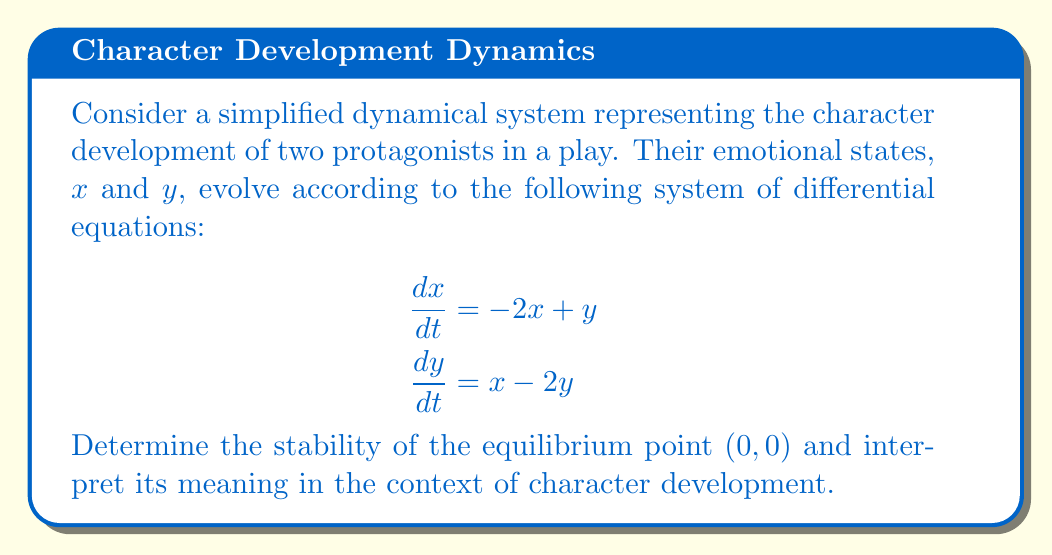Can you answer this question? To analyze the stability of the equilibrium point $(0,0)$, we'll follow these steps:

1) First, we need to find the Jacobian matrix of the system:

   $$J = \begin{bmatrix}
   \frac{\partial \dot{x}}{\partial x} & \frac{\partial \dot{x}}{\partial y} \\
   \frac{\partial \dot{y}}{\partial x} & \frac{\partial \dot{y}}{\partial y}
   \end{bmatrix} = \begin{bmatrix}
   -2 & 1 \\
   1 & -2
   \end{bmatrix}$$

2) Now, we calculate the eigenvalues of J by solving the characteristic equation:

   $$\det(J - \lambda I) = 0$$
   
   $$\begin{vmatrix}
   -2-\lambda & 1 \\
   1 & -2-\lambda
   \end{vmatrix} = 0$$
   
   $$(-2-\lambda)^2 - 1 = 0$$
   
   $$\lambda^2 + 4\lambda + 3 = 0$$

3) Solving this quadratic equation:

   $$\lambda = \frac{-4 \pm \sqrt{16 - 12}}{2} = \frac{-4 \pm \sqrt{4}}{2} = \frac{-4 \pm 2}{2}$$

   $$\lambda_1 = -3, \lambda_2 = -1$$

4) Since both eigenvalues are real and negative, the equilibrium point $(0,0)$ is a stable node.

5) Interpretation in the context of character development:
   - The stable node at $(0,0)$ represents a balanced emotional state for both characters.
   - Any perturbation from this state will eventually return to balance.
   - The eigenvalue $-1$ represents a slower approach to equilibrium, while $-3$ represents a faster approach.
   - This could be interpreted as the characters having different rates of emotional adjustment, but both ultimately finding stability.
Answer: Stable node; characters tend towards emotional balance at different rates. 